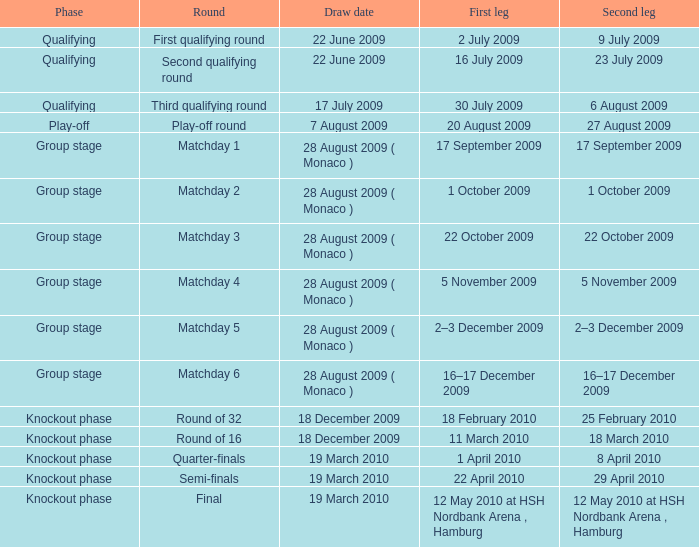Which phase is for the Matchday 4 Round? Group stage. Can you give me this table as a dict? {'header': ['Phase', 'Round', 'Draw date', 'First leg', 'Second leg'], 'rows': [['Qualifying', 'First qualifying round', '22 June 2009', '2 July 2009', '9 July 2009'], ['Qualifying', 'Second qualifying round', '22 June 2009', '16 July 2009', '23 July 2009'], ['Qualifying', 'Third qualifying round', '17 July 2009', '30 July 2009', '6 August 2009'], ['Play-off', 'Play-off round', '7 August 2009', '20 August 2009', '27 August 2009'], ['Group stage', 'Matchday 1', '28 August 2009 ( Monaco )', '17 September 2009', '17 September 2009'], ['Group stage', 'Matchday 2', '28 August 2009 ( Monaco )', '1 October 2009', '1 October 2009'], ['Group stage', 'Matchday 3', '28 August 2009 ( Monaco )', '22 October 2009', '22 October 2009'], ['Group stage', 'Matchday 4', '28 August 2009 ( Monaco )', '5 November 2009', '5 November 2009'], ['Group stage', 'Matchday 5', '28 August 2009 ( Monaco )', '2–3 December 2009', '2–3 December 2009'], ['Group stage', 'Matchday 6', '28 August 2009 ( Monaco )', '16–17 December 2009', '16–17 December 2009'], ['Knockout phase', 'Round of 32', '18 December 2009', '18 February 2010', '25 February 2010'], ['Knockout phase', 'Round of 16', '18 December 2009', '11 March 2010', '18 March 2010'], ['Knockout phase', 'Quarter-finals', '19 March 2010', '1 April 2010', '8 April 2010'], ['Knockout phase', 'Semi-finals', '19 March 2010', '22 April 2010', '29 April 2010'], ['Knockout phase', 'Final', '19 March 2010', '12 May 2010 at HSH Nordbank Arena , Hamburg', '12 May 2010 at HSH Nordbank Arena , Hamburg']]} 